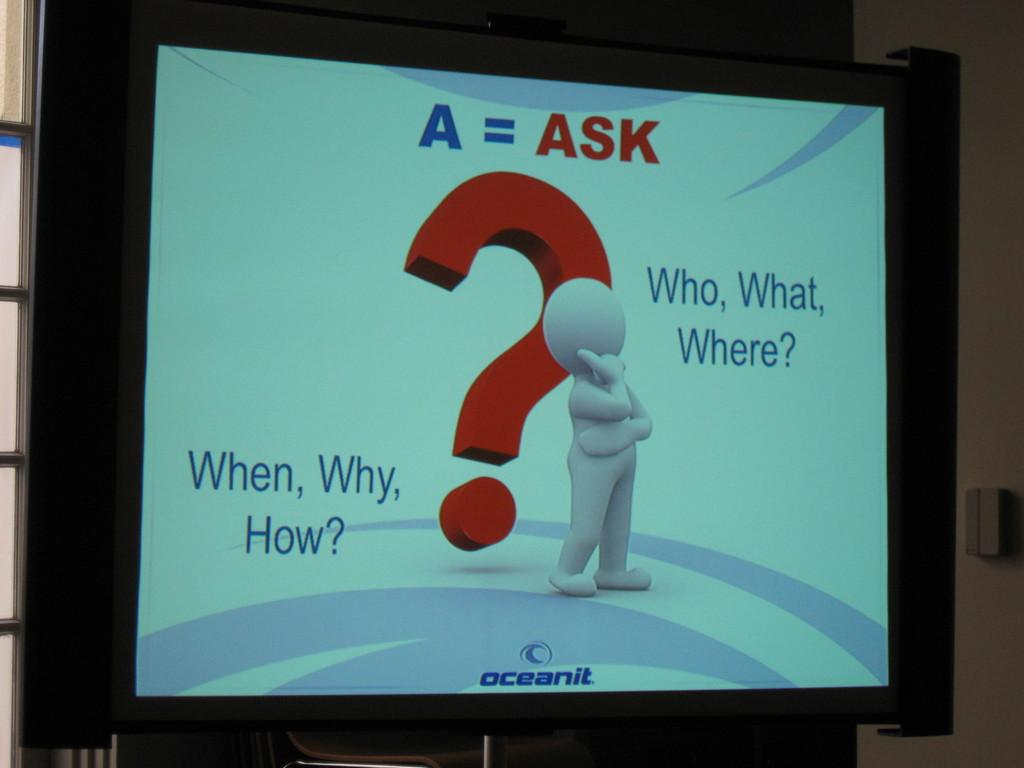<image>
Present a compact description of the photo's key features. A question mark s displayed on the screen and asks When, why and How. 